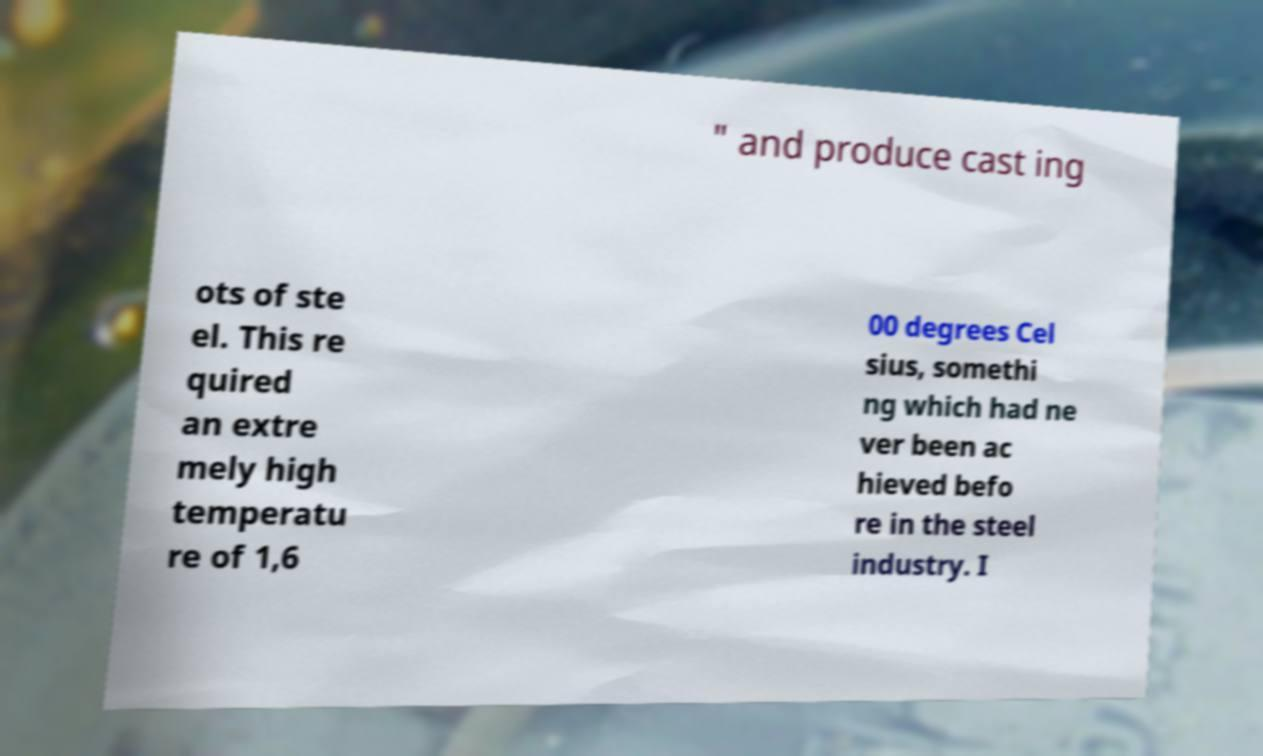For documentation purposes, I need the text within this image transcribed. Could you provide that? " and produce cast ing ots of ste el. This re quired an extre mely high temperatu re of 1,6 00 degrees Cel sius, somethi ng which had ne ver been ac hieved befo re in the steel industry. I 